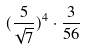Convert formula to latex. <formula><loc_0><loc_0><loc_500><loc_500>( \frac { 5 } { \sqrt { 7 } } ) ^ { 4 } \cdot \frac { 3 } { 5 6 }</formula> 